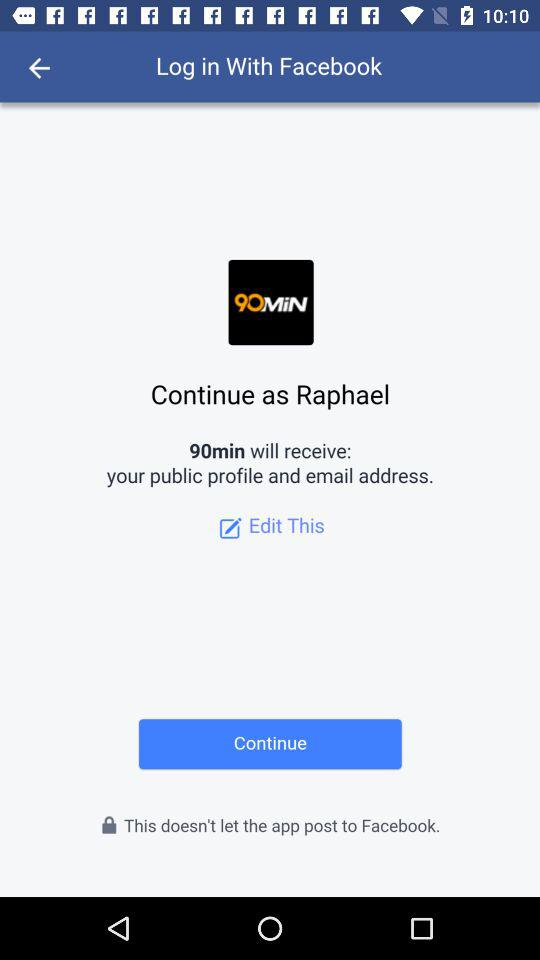What application is used to log in? The application "Facebook" is used to log in. 